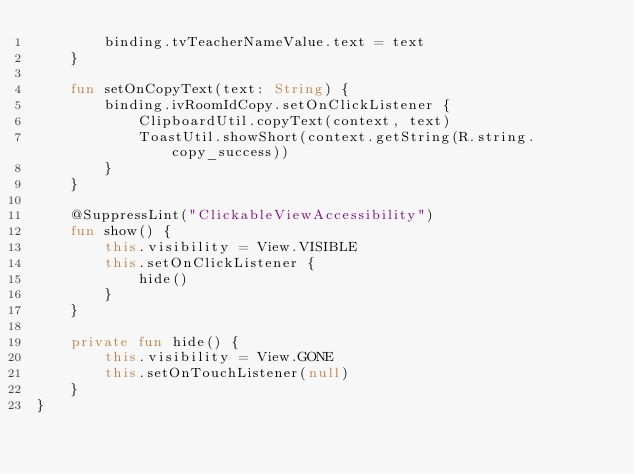Convert code to text. <code><loc_0><loc_0><loc_500><loc_500><_Kotlin_>        binding.tvTeacherNameValue.text = text
    }

    fun setOnCopyText(text: String) {
        binding.ivRoomIdCopy.setOnClickListener {
            ClipboardUtil.copyText(context, text)
            ToastUtil.showShort(context.getString(R.string.copy_success))
        }
    }

    @SuppressLint("ClickableViewAccessibility")
    fun show() {
        this.visibility = View.VISIBLE
        this.setOnClickListener {
            hide()
        }
    }

    private fun hide() {
        this.visibility = View.GONE
        this.setOnTouchListener(null)
    }
}</code> 